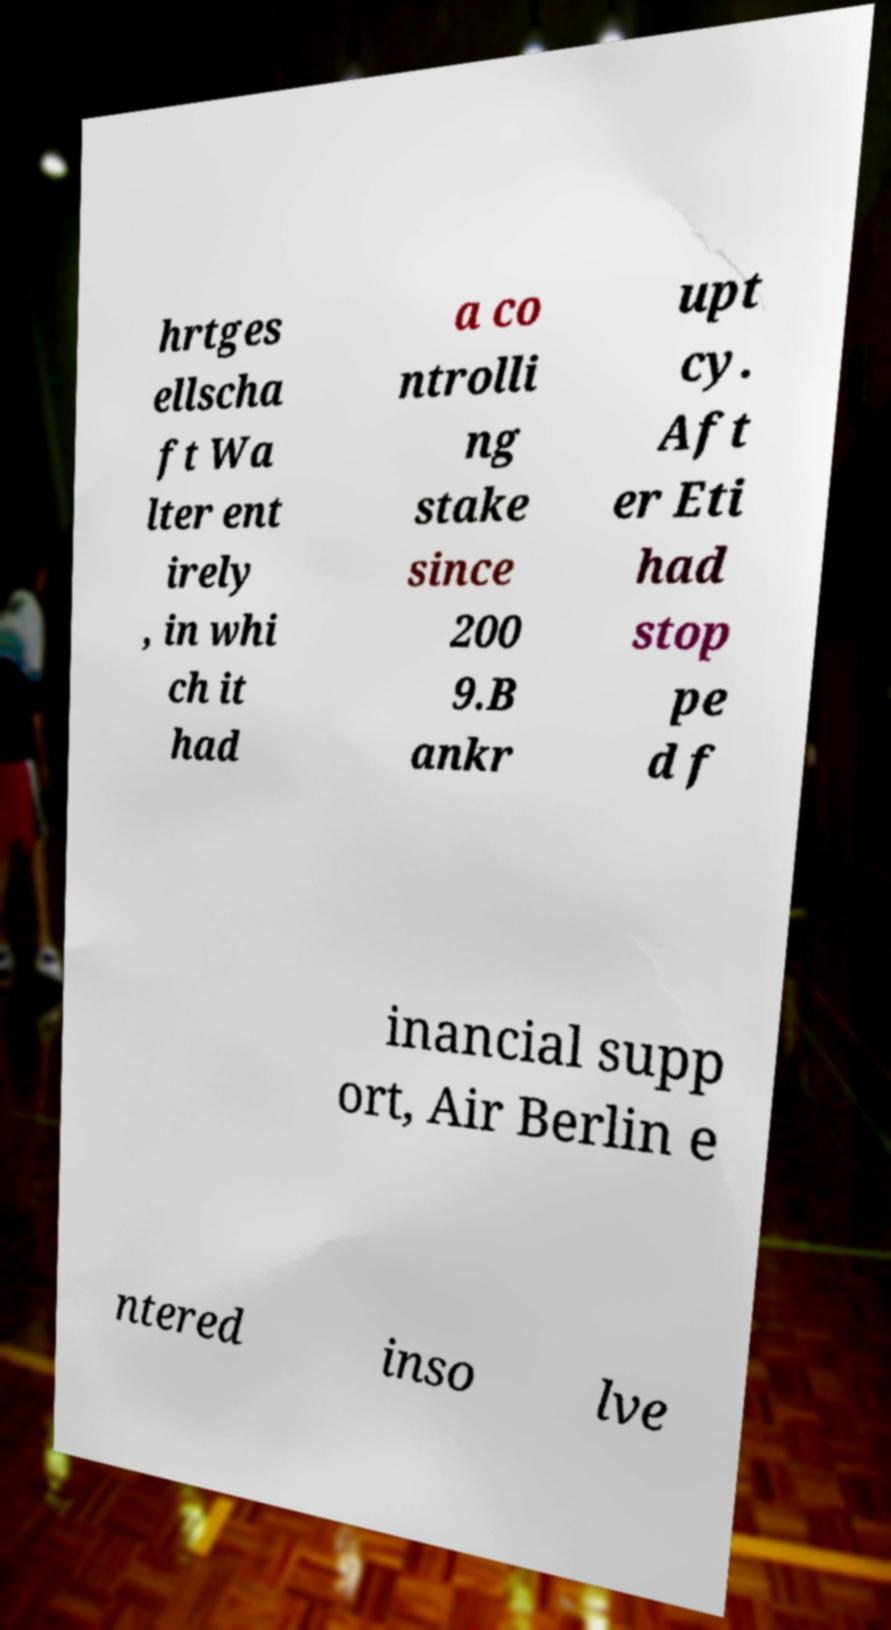Could you extract and type out the text from this image? hrtges ellscha ft Wa lter ent irely , in whi ch it had a co ntrolli ng stake since 200 9.B ankr upt cy. Aft er Eti had stop pe d f inancial supp ort, Air Berlin e ntered inso lve 